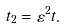<formula> <loc_0><loc_0><loc_500><loc_500>t _ { 2 } = \varepsilon ^ { 2 } t .</formula> 